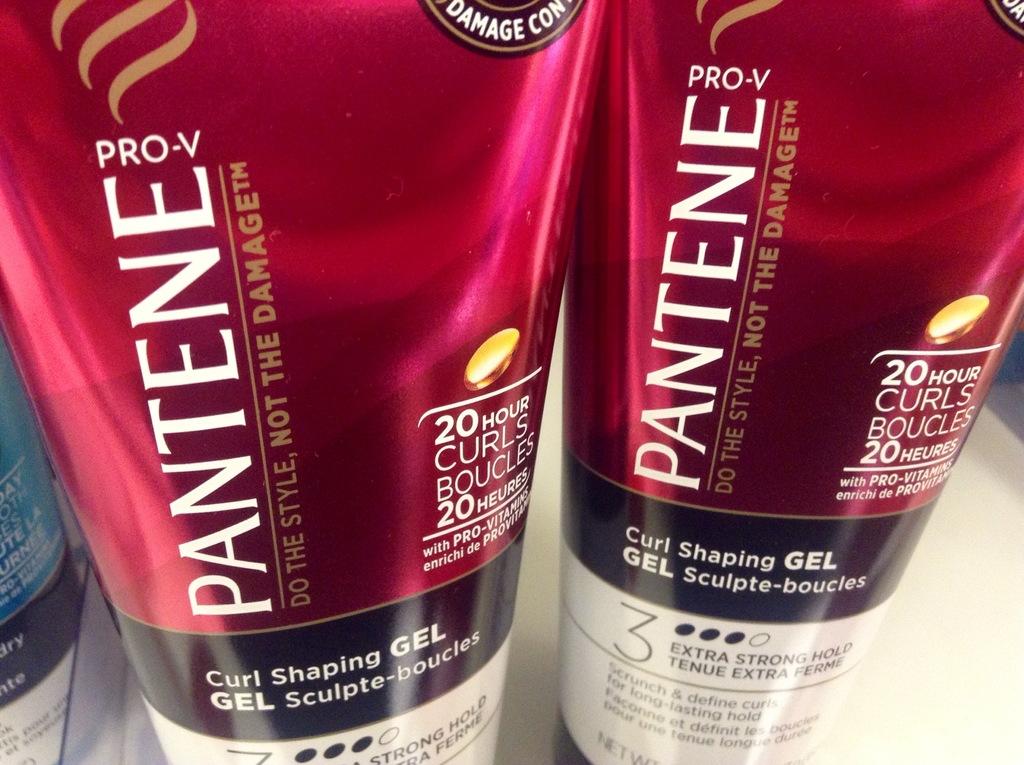What hair care product is this?
Your answer should be very brief. Curl shaping gel. What is the brand?
Your answer should be very brief. Pantene. 